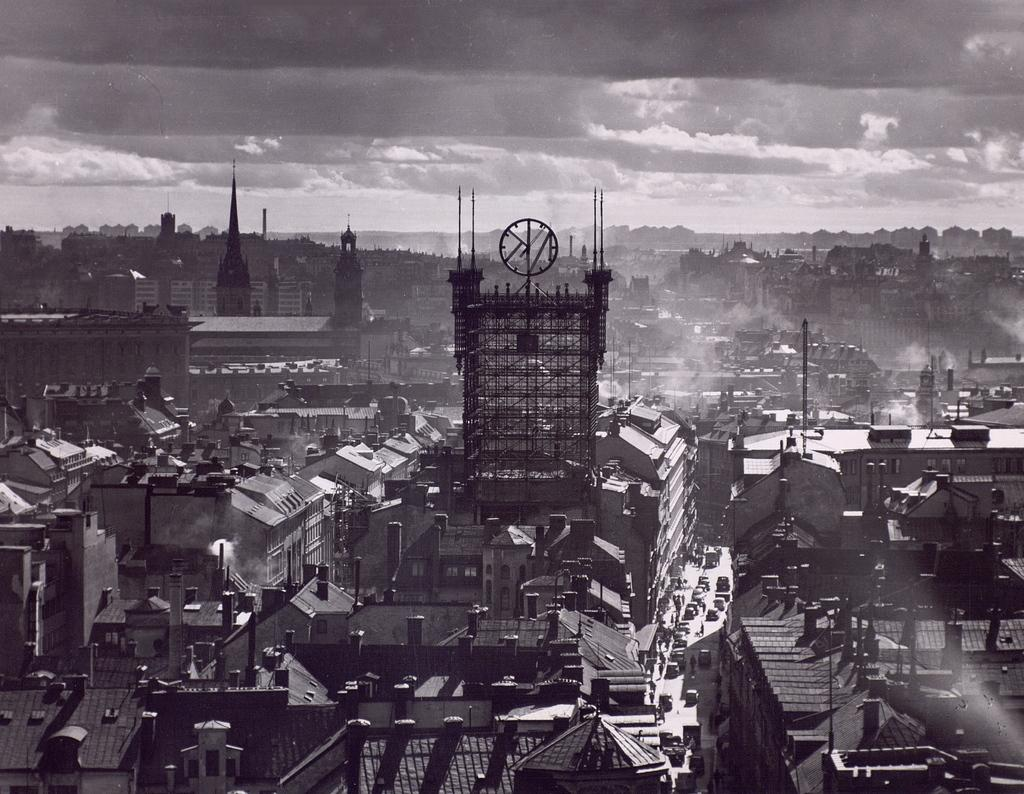What type of structures can be seen in the image? There are buildings in the image. What is visible at the top of the image? The sky is visible at the top of the image. What can be observed in the sky? Clouds are present in the sky. What type of pump is visible in the image? There is no pump present in the image. What disease can be seen affecting the buildings in the image? There is no disease present in the image, and the buildings appear to be in good condition. 